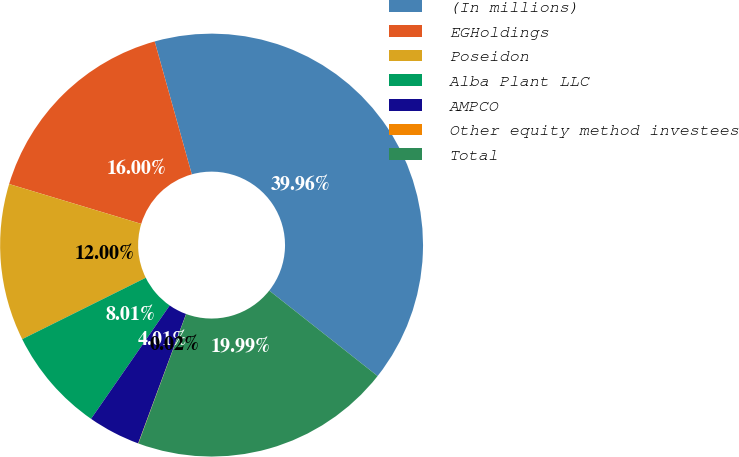<chart> <loc_0><loc_0><loc_500><loc_500><pie_chart><fcel>(In millions)<fcel>EGHoldings<fcel>Poseidon<fcel>Alba Plant LLC<fcel>AMPCO<fcel>Other equity method investees<fcel>Total<nl><fcel>39.96%<fcel>16.0%<fcel>12.0%<fcel>8.01%<fcel>4.01%<fcel>0.02%<fcel>19.99%<nl></chart> 